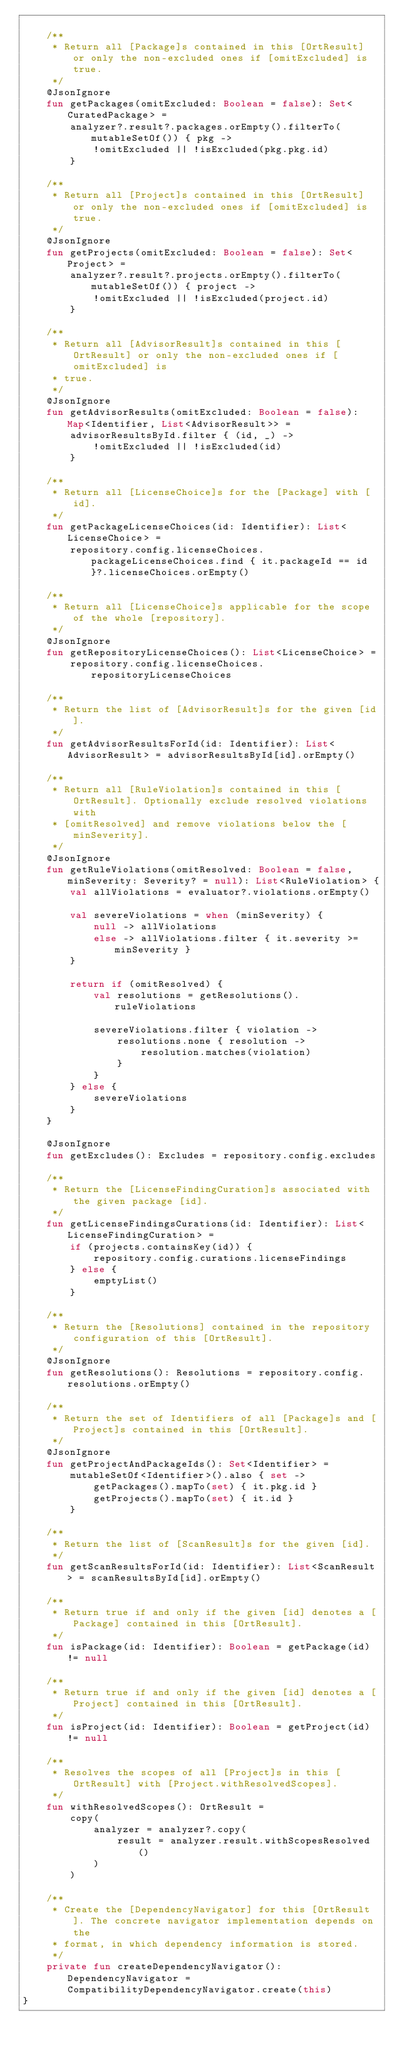<code> <loc_0><loc_0><loc_500><loc_500><_Kotlin_>
    /**
     * Return all [Package]s contained in this [OrtResult] or only the non-excluded ones if [omitExcluded] is true.
     */
    @JsonIgnore
    fun getPackages(omitExcluded: Boolean = false): Set<CuratedPackage> =
        analyzer?.result?.packages.orEmpty().filterTo(mutableSetOf()) { pkg ->
            !omitExcluded || !isExcluded(pkg.pkg.id)
        }

    /**
     * Return all [Project]s contained in this [OrtResult] or only the non-excluded ones if [omitExcluded] is true.
     */
    @JsonIgnore
    fun getProjects(omitExcluded: Boolean = false): Set<Project> =
        analyzer?.result?.projects.orEmpty().filterTo(mutableSetOf()) { project ->
            !omitExcluded || !isExcluded(project.id)
        }

    /**
     * Return all [AdvisorResult]s contained in this [OrtResult] or only the non-excluded ones if [omitExcluded] is
     * true.
     */
    @JsonIgnore
    fun getAdvisorResults(omitExcluded: Boolean = false): Map<Identifier, List<AdvisorResult>> =
        advisorResultsById.filter { (id, _) ->
            !omitExcluded || !isExcluded(id)
        }

    /**
     * Return all [LicenseChoice]s for the [Package] with [id].
     */
    fun getPackageLicenseChoices(id: Identifier): List<LicenseChoice> =
        repository.config.licenseChoices.packageLicenseChoices.find { it.packageId == id }?.licenseChoices.orEmpty()

    /**
     * Return all [LicenseChoice]s applicable for the scope of the whole [repository].
     */
    @JsonIgnore
    fun getRepositoryLicenseChoices(): List<LicenseChoice> =
        repository.config.licenseChoices.repositoryLicenseChoices

    /**
     * Return the list of [AdvisorResult]s for the given [id].
     */
    fun getAdvisorResultsForId(id: Identifier): List<AdvisorResult> = advisorResultsById[id].orEmpty()

    /**
     * Return all [RuleViolation]s contained in this [OrtResult]. Optionally exclude resolved violations with
     * [omitResolved] and remove violations below the [minSeverity].
     */
    @JsonIgnore
    fun getRuleViolations(omitResolved: Boolean = false, minSeverity: Severity? = null): List<RuleViolation> {
        val allViolations = evaluator?.violations.orEmpty()

        val severeViolations = when (minSeverity) {
            null -> allViolations
            else -> allViolations.filter { it.severity >= minSeverity }
        }

        return if (omitResolved) {
            val resolutions = getResolutions().ruleViolations

            severeViolations.filter { violation ->
                resolutions.none { resolution ->
                    resolution.matches(violation)
                }
            }
        } else {
            severeViolations
        }
    }

    @JsonIgnore
    fun getExcludes(): Excludes = repository.config.excludes

    /**
     * Return the [LicenseFindingCuration]s associated with the given package [id].
     */
    fun getLicenseFindingsCurations(id: Identifier): List<LicenseFindingCuration> =
        if (projects.containsKey(id)) {
            repository.config.curations.licenseFindings
        } else {
            emptyList()
        }

    /**
     * Return the [Resolutions] contained in the repository configuration of this [OrtResult].
     */
    @JsonIgnore
    fun getResolutions(): Resolutions = repository.config.resolutions.orEmpty()

    /**
     * Return the set of Identifiers of all [Package]s and [Project]s contained in this [OrtResult].
     */
    @JsonIgnore
    fun getProjectAndPackageIds(): Set<Identifier> =
        mutableSetOf<Identifier>().also { set ->
            getPackages().mapTo(set) { it.pkg.id }
            getProjects().mapTo(set) { it.id }
        }

    /**
     * Return the list of [ScanResult]s for the given [id].
     */
    fun getScanResultsForId(id: Identifier): List<ScanResult> = scanResultsById[id].orEmpty()

    /**
     * Return true if and only if the given [id] denotes a [Package] contained in this [OrtResult].
     */
    fun isPackage(id: Identifier): Boolean = getPackage(id) != null

    /**
     * Return true if and only if the given [id] denotes a [Project] contained in this [OrtResult].
     */
    fun isProject(id: Identifier): Boolean = getProject(id) != null

    /**
     * Resolves the scopes of all [Project]s in this [OrtResult] with [Project.withResolvedScopes].
     */
    fun withResolvedScopes(): OrtResult =
        copy(
            analyzer = analyzer?.copy(
                result = analyzer.result.withScopesResolved()
            )
        )

    /**
     * Create the [DependencyNavigator] for this [OrtResult]. The concrete navigator implementation depends on the
     * format, in which dependency information is stored.
     */
    private fun createDependencyNavigator(): DependencyNavigator = CompatibilityDependencyNavigator.create(this)
}
</code> 